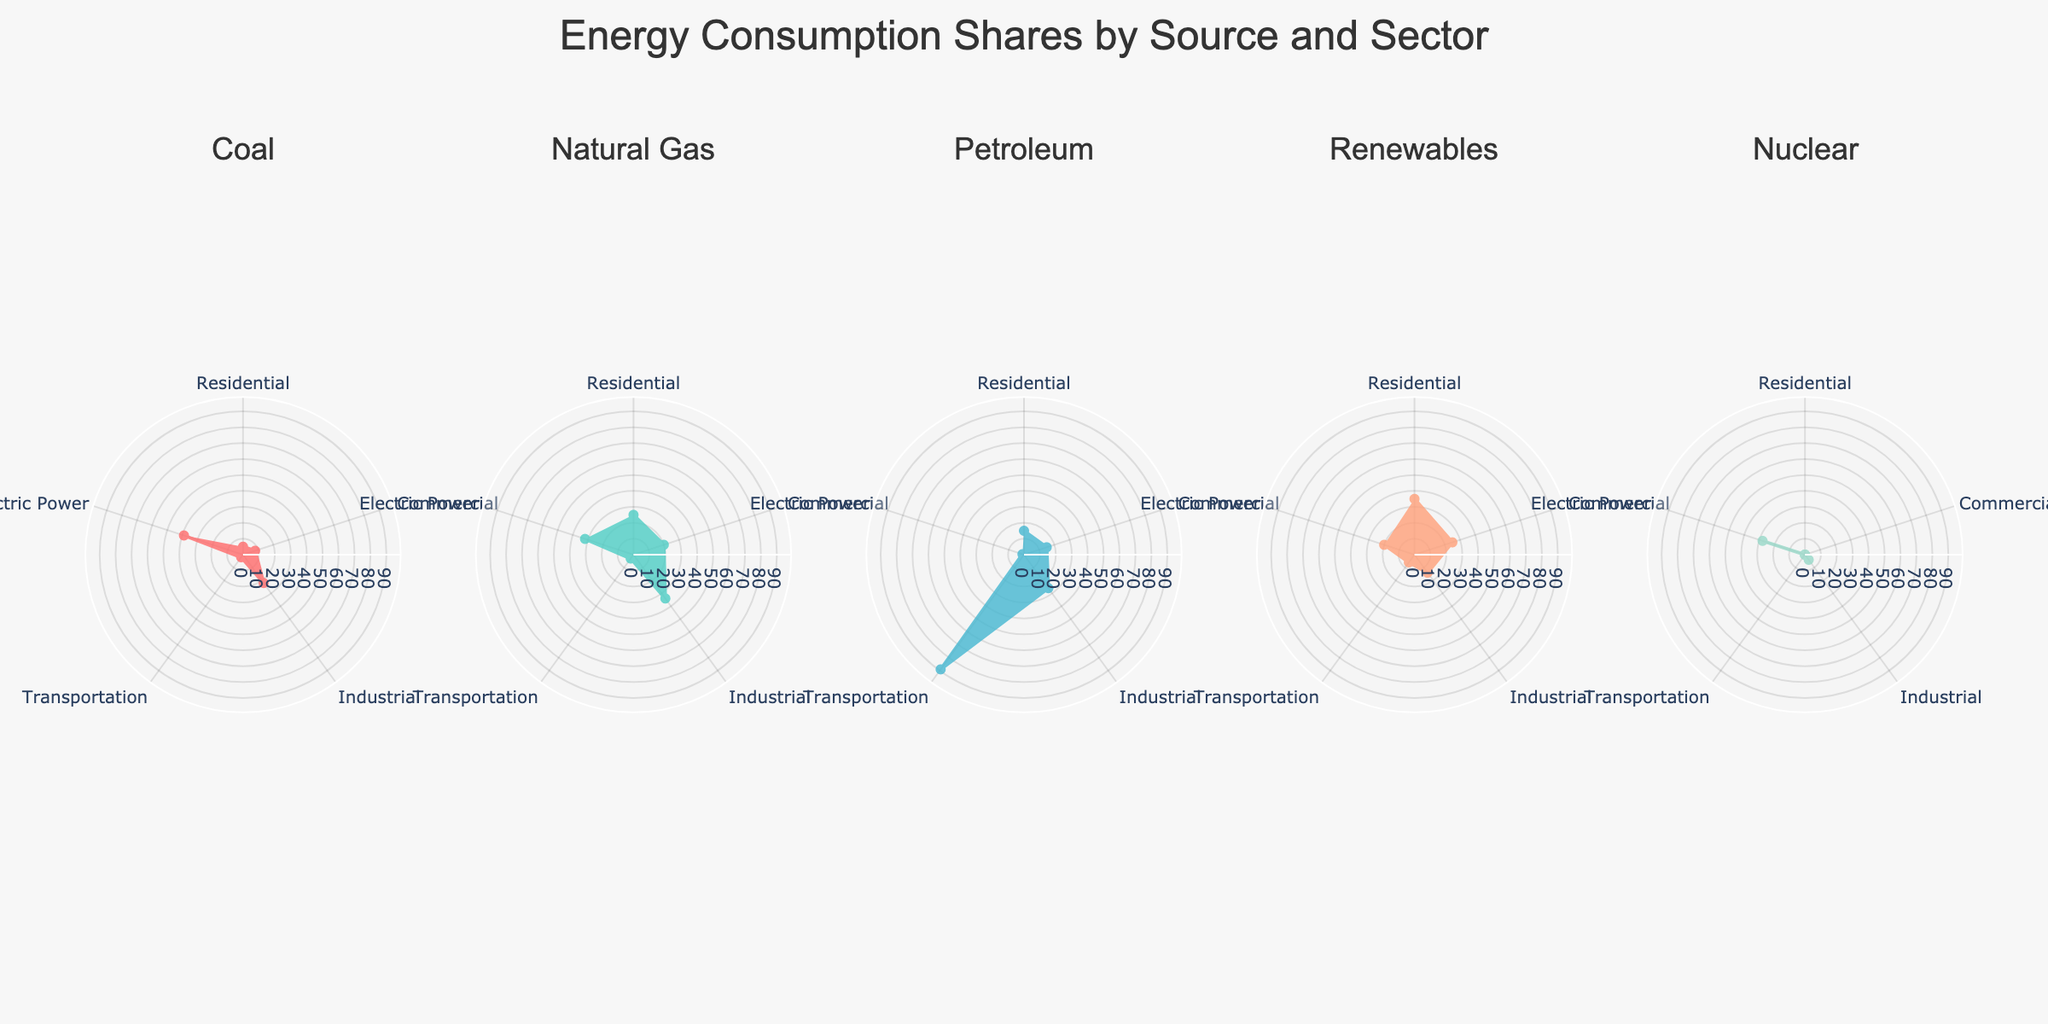what sectors appear on the charts? The charts display five sectors: Residential, Commercial, Industrial, Transportation, and Electric Power, as shown along the angular axis of each subplot.
Answer: Residential, Commercial, Industrial, Transportation, Electric Power Which source has the highest share of energy consumption for the Transportation sector? For the Transportation sector, looking at the subplots, the Petroleum source has the highest share with a value of 89.
Answer: Petroleum What is the range of the radial axis for each subplot? Each subplot has a radial axis range marked from 0 to the maximum share value found in the data, which is 89, with an additional buffer of 10, making the range from 0 to 99.
Answer: 0 to 99 Which source has zero energy consumption in the Residential sector? Examination of the Residential sector in all subplots shows that Nuclear has a share of zero.
Answer: Nuclear Compare the energy consumption shares of Coal and Natural Gas in the Industrial sector. Which is higher? The shares for Coal and Natural Gas in the Industrial sector are 22 and 34 respectively. Hence, Natural Gas has a higher share.
Answer: Natural Gas What is the combined energy consumption share of Renewables in the Residential and Commercial sectors? The shares for Renewables are 35 in Residential and 25 in Commercial, so the combined share is 35 + 25 = 60.
Answer: 60 How does the share of Nuclear energy in the Electric Power sector compare to the share in the Residential sector? The share of Nuclear energy in the Electric Power sector is 28, while it has zero share in the Residential sector, so Nuclear's share is significantly higher in Electric Power.
Answer: significantly higher For which sector does Coal have the largest energy consumption share? The sector with the largest share for Coal is Electric Power, with a share of 39.
Answer: Electric Power Describe the color coding used in the charts. Each energy source is represented by a unique color across all subplots: Coal is red, Natural Gas is teal, Petroleum is dark blue, Renewables is light orange, and Nuclear is light green.
Answer: Coal is red, Natural Gas is teal, Petroleum is dark blue, Renewables is light orange, Nuclear is light green Identify the sector with the smallest energy share for Renewables. The smallest energy share for Renewables is in the Transportation sector, with a share of 6.
Answer: Transportation 